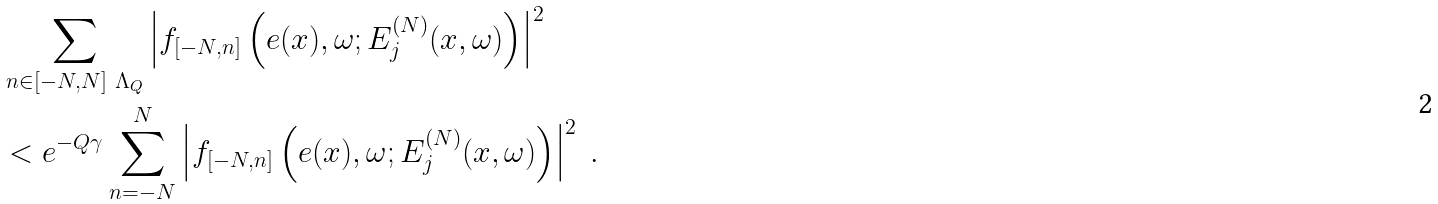<formula> <loc_0><loc_0><loc_500><loc_500>& \sum _ { n \in [ - N , N ] \ \Lambda _ { Q } } \left | f _ { [ - N , n ] } \left ( e ( x ) , \omega ; E _ { j } ^ { ( N ) } ( x , \omega ) \right ) \right | ^ { 2 } \\ & < e ^ { - Q \gamma } \sum ^ { N } _ { n = - N } \left | f _ { [ - N , n ] } \left ( e ( x ) , \omega ; E _ { j } ^ { ( N ) } ( x , \omega ) \right ) \right | ^ { 2 } \ .</formula> 